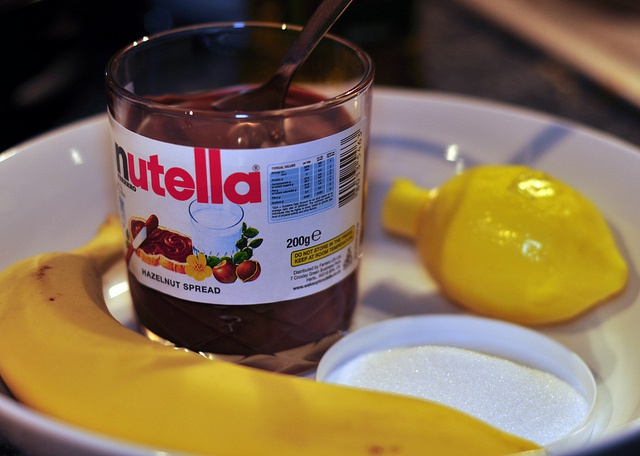Describe the objects in this image and their specific colors. I can see banana in black, orange, olive, and tan tones and spoon in black, maroon, brown, and purple tones in this image. 